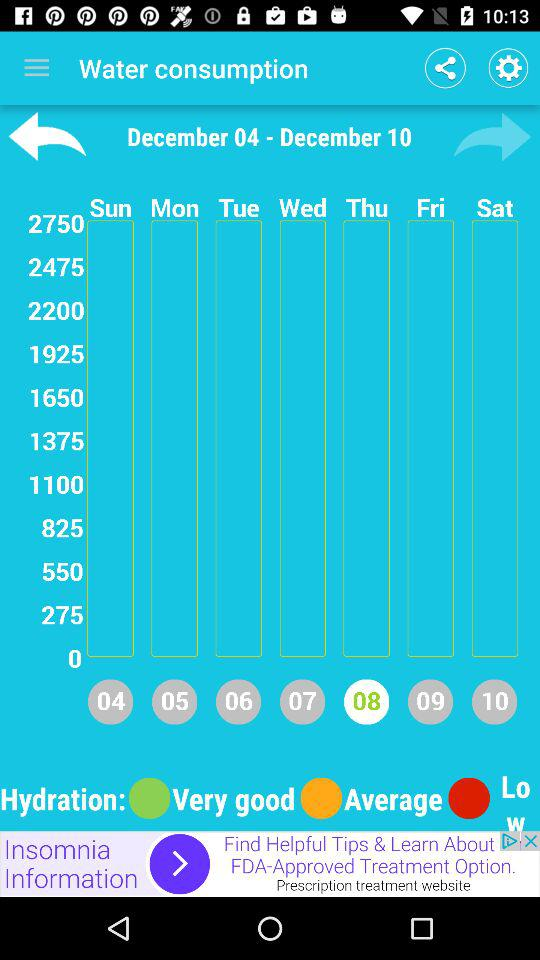What day is on December 8? The day on December 8 is Thursday. 